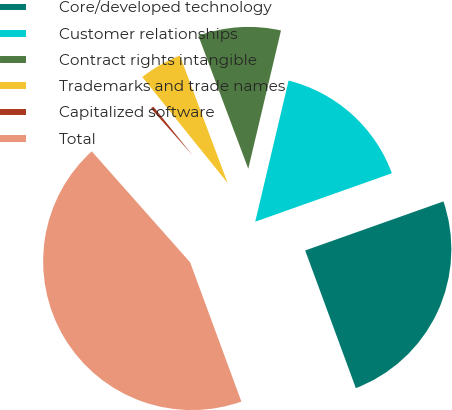Convert chart to OTSL. <chart><loc_0><loc_0><loc_500><loc_500><pie_chart><fcel>Core/developed technology<fcel>Customer relationships<fcel>Contract rights intangible<fcel>Trademarks and trade names<fcel>Capitalized software<fcel>Total<nl><fcel>24.81%<fcel>15.88%<fcel>9.41%<fcel>5.08%<fcel>0.75%<fcel>44.07%<nl></chart> 